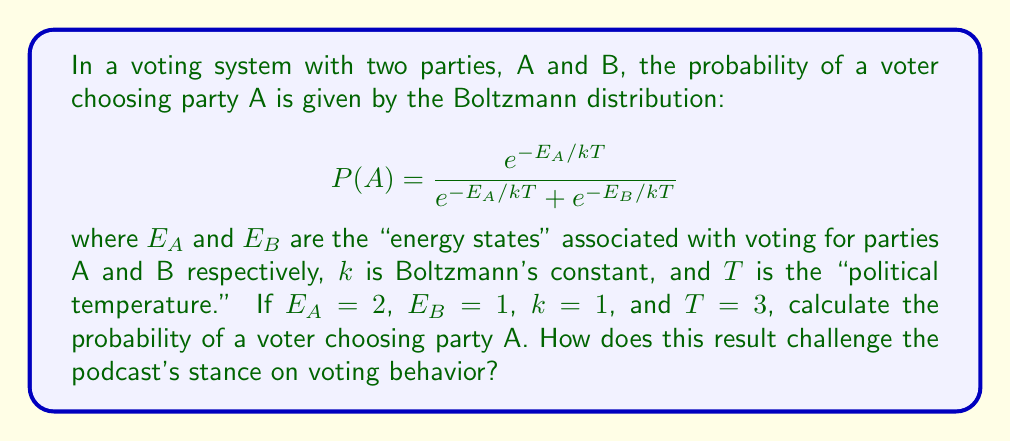Provide a solution to this math problem. To solve this problem, we'll follow these steps:

1) First, let's substitute the given values into the Boltzmann distribution formula:

   $$P(A) = \frac{e^{-E_A/kT}}{e^{-E_A/kT} + e^{-E_B/kT}}$$

   $$P(A) = \frac{e^{-2/(1*3)}}{e^{-2/(1*3)} + e^{-1/(1*3)}}$$

2) Simplify the exponents:

   $$P(A) = \frac{e^{-2/3}}{e^{-2/3} + e^{-1/3}}$$

3) Calculate the values of $e^{-2/3}$ and $e^{-1/3}$:

   $e^{-2/3} \approx 0.5134$
   $e^{-1/3} \approx 0.7165$

4) Substitute these values:

   $$P(A) = \frac{0.5134}{0.5134 + 0.7165}$$

5) Calculate the final probability:

   $$P(A) = \frac{0.5134}{1.2299} \approx 0.4174$$

This result shows that despite party B having a lower "energy state" (which could represent factors like campaign effectiveness, policy appeal, etc.), party A still has a significant probability of being chosen (about 41.74%).

This challenges the podcast's stance by demonstrating that voting behavior is not deterministic or solely based on obvious factors. Even when one party seems to have an advantage (lower energy state), there's still a substantial probability for voters to choose the other party. This supports a more nuanced view of voting patterns, considering factors like individual voter preferences, information asymmetry, and the inherent unpredictability in human decision-making.
Answer: $P(A) \approx 0.4174$ 